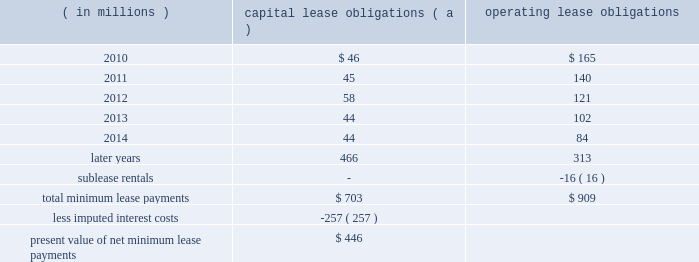Marathon oil corporation notes to consolidated financial statements equivalent to the exchangeable shares at the acquisition date as discussed below .
Additional shares of voting preferred stock will be issued as necessary to adjust the number of votes to account for changes in the exchange ratio .
Preferred shares 2013 in connection with the acquisition of western discussed in note 6 , the board of directors authorized a class of voting preferred stock consisting of 6 million shares .
Upon completion of the acquisition , we issued 5 million shares of this voting preferred stock to a trustee , who holds the shares for the benefit of the holders of the exchangeable shares discussed above .
Each share of voting preferred stock is entitled to one vote on all matters submitted to the holders of marathon common stock .
Each holder of exchangeable shares may direct the trustee to vote the number of shares of voting preferred stock equal to the number of shares of marathon common stock issuable upon the exchange of the exchangeable shares held by that holder .
In no event will the aggregate number of votes entitled to be cast by the trustee with respect to the outstanding shares of voting preferred stock exceed the number of votes entitled to be cast with respect to the outstanding exchangeable shares .
Except as otherwise provided in our restated certificate of incorporation or by applicable law , the common stock and the voting preferred stock will vote together as a single class in the election of directors of marathon and on all other matters submitted to a vote of stockholders of marathon generally .
The voting preferred stock will have no other voting rights except as required by law .
Other than dividends payable solely in shares of voting preferred stock , no dividend or other distribution , will be paid or payable to the holder of the voting preferred stock .
In the event of any liquidation , dissolution or winding up of marathon , the holder of shares of the voting preferred stock will not be entitled to receive any assets of marathon available for distribution to its stockholders .
The voting preferred stock is not convertible into any other class or series of the capital stock of marathon or into cash , property or other rights , and may not be redeemed .
25 .
Leases we lease a wide variety of facilities and equipment under operating leases , including land and building space , office equipment , production facilities and transportation equipment .
Most long-term leases include renewal options and , in certain leases , purchase options .
Future minimum commitments for capital lease obligations ( including sale-leasebacks accounted for as financings ) and for operating lease obligations having initial or remaining noncancelable lease terms in excess of one year are as follows : ( in millions ) capital lease obligations ( a ) operating obligations .
( a ) capital lease obligations include $ 164 million related to assets under construction as of december 31 , 2009 .
These leases are currently reported in long-term debt based on percentage of construction completed at $ 36 million .
In connection with past sales of various plants and operations , we assigned and the purchasers assumed certain leases of major equipment used in the divested plants and operations of united states steel .
In the event of a default by any of the purchasers , united states steel has assumed these obligations ; however , we remain primarily obligated for payments under these leases .
Minimum lease payments under these operating lease obligations of $ 16 million have been included above and an equal amount has been reported as sublease rentals. .
What percentage of operating leases are due currently? 
Computations: (165 / 909)
Answer: 0.18152. 